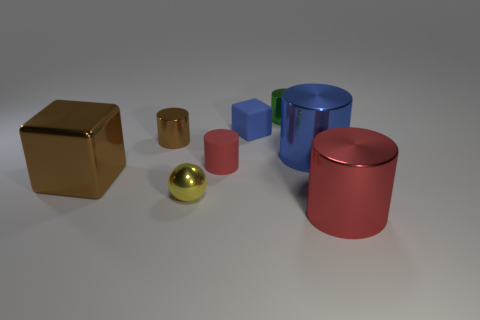There is a red thing behind the red shiny thing; does it have the same shape as the large thing that is in front of the big brown cube?
Offer a very short reply. Yes. Is there a blue sphere that has the same material as the small blue object?
Offer a very short reply. No. What number of green things are big shiny blocks or tiny cylinders?
Your response must be concise. 1. How big is the thing that is behind the small brown cylinder and in front of the small green metal cylinder?
Keep it short and to the point. Small. Are there more big brown metal objects that are behind the small red rubber cylinder than cyan metallic spheres?
Your response must be concise. No. How many cylinders are large red things or large blue things?
Ensure brevity in your answer.  2. The tiny shiny thing that is both behind the small red matte cylinder and right of the tiny brown thing has what shape?
Give a very brief answer. Cylinder. Is the number of red cylinders that are left of the small green shiny cylinder the same as the number of big cylinders that are left of the blue metallic cylinder?
Provide a short and direct response. No. What number of things are either spheres or large brown blocks?
Ensure brevity in your answer.  2. What is the color of the sphere that is the same size as the green shiny thing?
Provide a short and direct response. Yellow. 